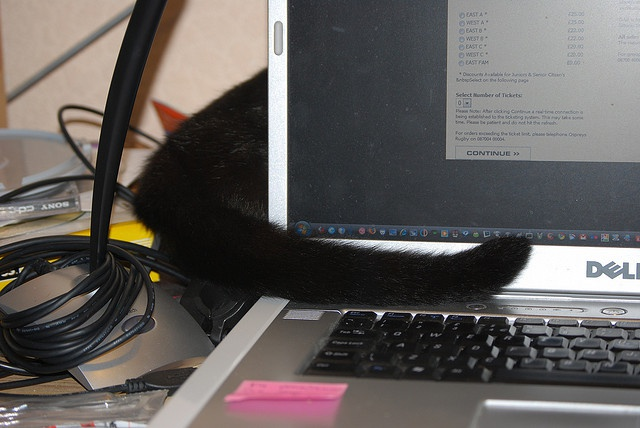Describe the objects in this image and their specific colors. I can see laptop in gray, black, darkgray, and white tones and cat in gray, black, darkgray, and lightgray tones in this image. 